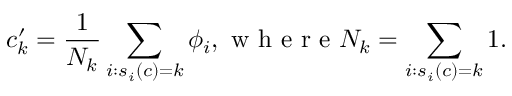<formula> <loc_0><loc_0><loc_500><loc_500>{ c _ { k } ^ { \prime } = \frac { 1 } { N _ { k } } \sum _ { i \colon s _ { i } ( c ) = k } \phi _ { i } , w h e r e N _ { k } = \sum _ { i \colon s _ { i } ( c ) = k } 1 } .</formula> 